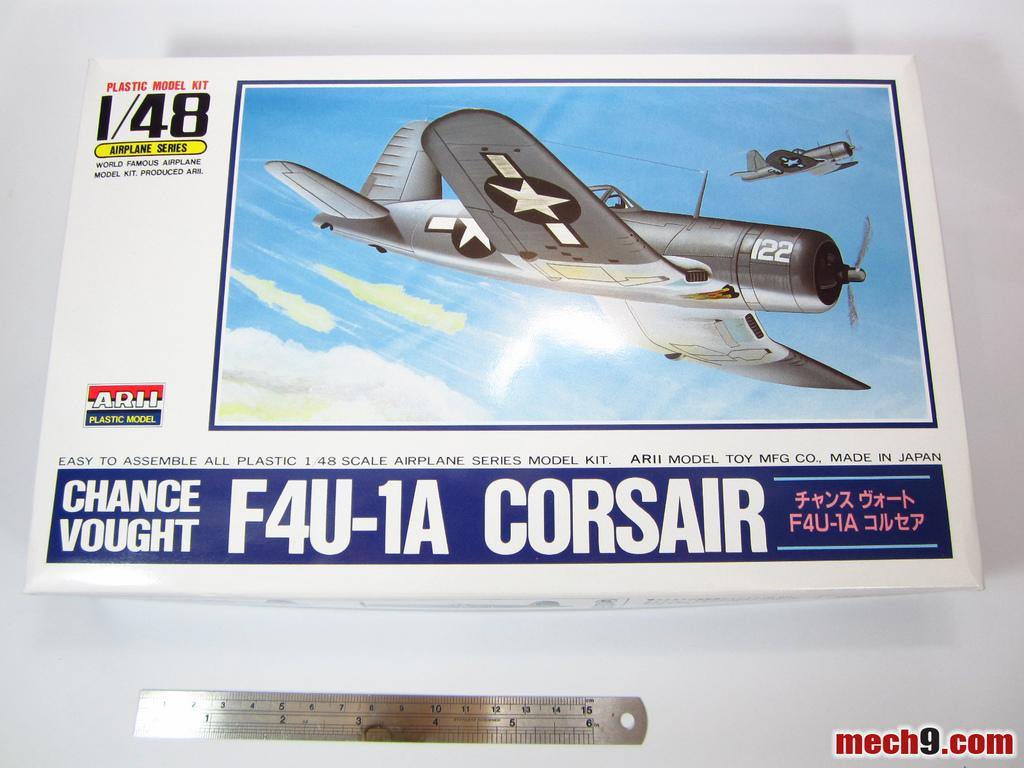<image>
Describe the image concisely. An advertisement of a plastic model kit l/48 airplane series. 